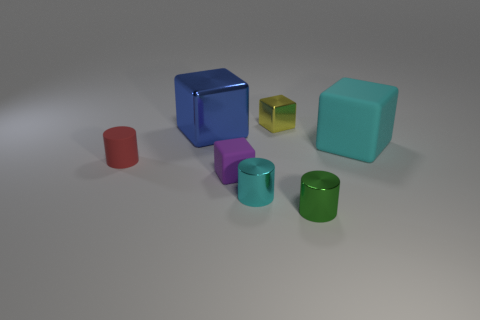There is a tiny matte thing on the right side of the tiny red thing on the left side of the green cylinder; what is its color?
Provide a succinct answer. Purple. Is there anything else that has the same size as the cyan block?
Keep it short and to the point. Yes. Do the large blue metallic object in front of the small yellow metallic cube and the purple thing have the same shape?
Keep it short and to the point. Yes. How many small rubber things are both to the left of the small rubber cube and on the right side of the red matte cylinder?
Offer a very short reply. 0. There is a tiny cylinder that is to the left of the big block that is left of the tiny yellow shiny thing to the right of the large blue metal cube; what color is it?
Your answer should be compact. Red. There is a tiny block that is in front of the cyan matte cube; how many cyan things are in front of it?
Offer a very short reply. 1. How many other objects are there of the same shape as the blue shiny object?
Your response must be concise. 3. How many objects are either tiny red cylinders or cyan objects that are behind the red cylinder?
Provide a succinct answer. 2. Is the number of purple cubes behind the blue metal cube greater than the number of tiny red rubber cylinders that are to the right of the matte cylinder?
Keep it short and to the point. No. There is a tiny matte thing to the right of the thing to the left of the large cube that is left of the tiny green cylinder; what is its shape?
Your response must be concise. Cube. 